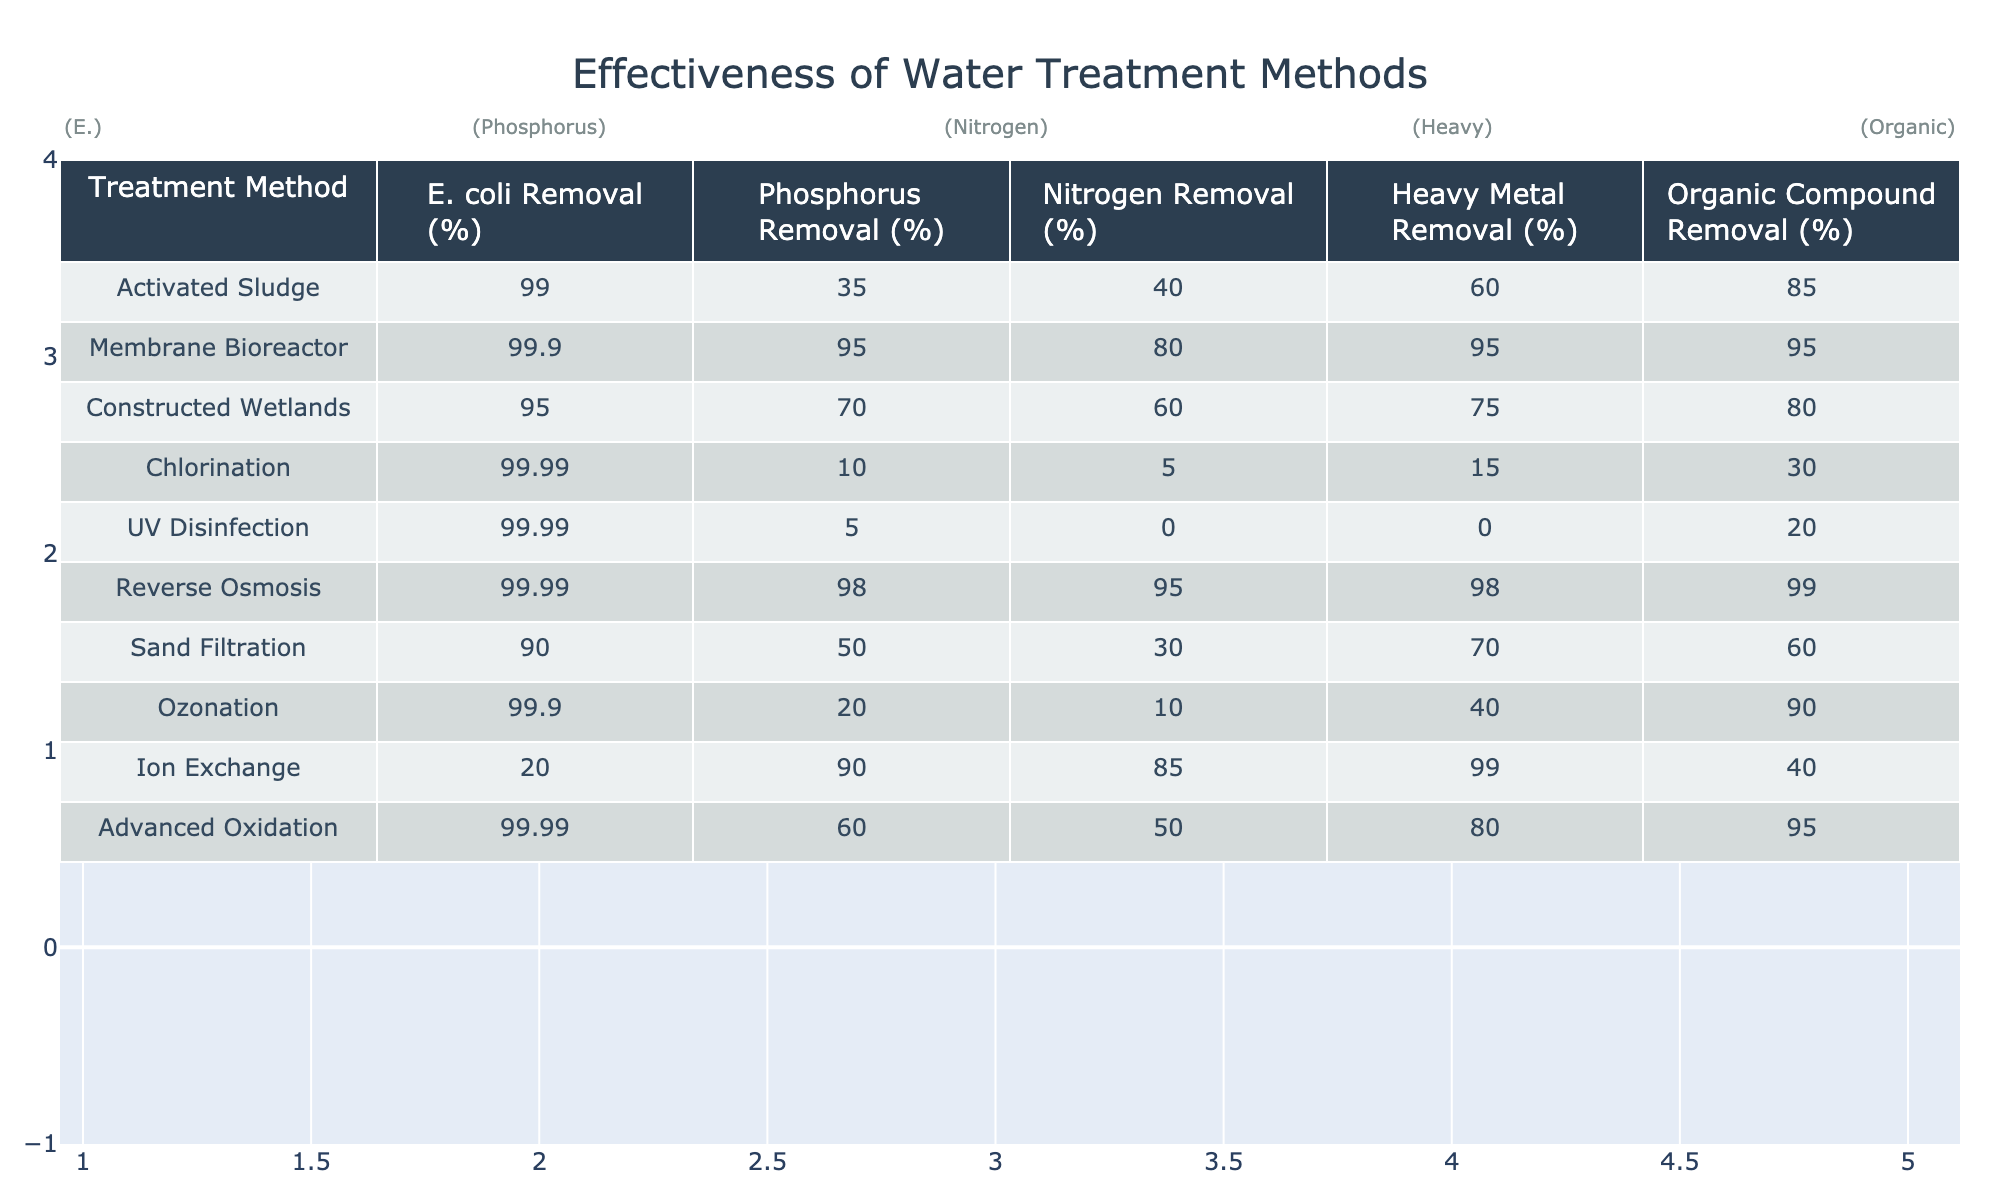What is the E. coli removal percentage for Reverse Osmosis? The table shows that Reverse Osmosis has an E. coli removal percentage of 99.99.
Answer: 99.99 Which treatment method provides the highest removal percentage for Nitrogen? Upon reviewing the table, Membrane Bioreactor has the highest Nitrogen removal percentage at 80.
Answer: 80 What is the difference in Heavy Metal removal percentage between Ion Exchange and Sand Filtration? The Heavy Metal removal percentage for Ion Exchange is 99 and for Sand Filtration it is 70. The difference is 99 - 70 = 29.
Answer: 29 Does Chlorination remove more organic compounds than Sand Filtration? Chlorination has an Organic Compound removal percentage of 30, while Sand Filtration has a percentage of 60. Therefore, the statement is false.
Answer: No What is the average removal percentage of Phosphorus across all treatment methods? To find the average, sum the Phosphorus removal percentages (35 + 95 + 70 + 10 + 5 + 98 + 50 + 20 + 90 + 60) =  525. There are 10 treatment methods, so the average is 525 / 10 = 52.5.
Answer: 52.5 Which treatment methods remove more than 90% of E. coli? According to the table, Activated Sludge, Membrane Bioreactor, Chlorination, and UV Disinfection all have E. coli removal percentages of 90 or higher.
Answer: 4 Methods Is the Heavy Metal removal percentage for Constructed Wetlands greater than 60%? The table indicates that Constructed Wetlands have a Heavy Metal removal percentage of 75, which is indeed greater than 60%. Thus, the statement is true.
Answer: Yes What is the combined percentage of Organic Compound removal for both Ozonation and Advanced Oxidation? The Organic Compound removal percentage for Ozonation is 90 and for Advanced Oxidation is 95. Their sum is 90 + 95 = 185.
Answer: 185 What percentage of Phosphorus does UV Disinfection remove? The table states that UV Disinfection removes 5% of Phosphorus.
Answer: 5 Which treatment method has the lowest Nitrogen removal percentage? Upon examination, UV Disinfection has the lowest Nitrogen removal percentage at 0.
Answer: 0 